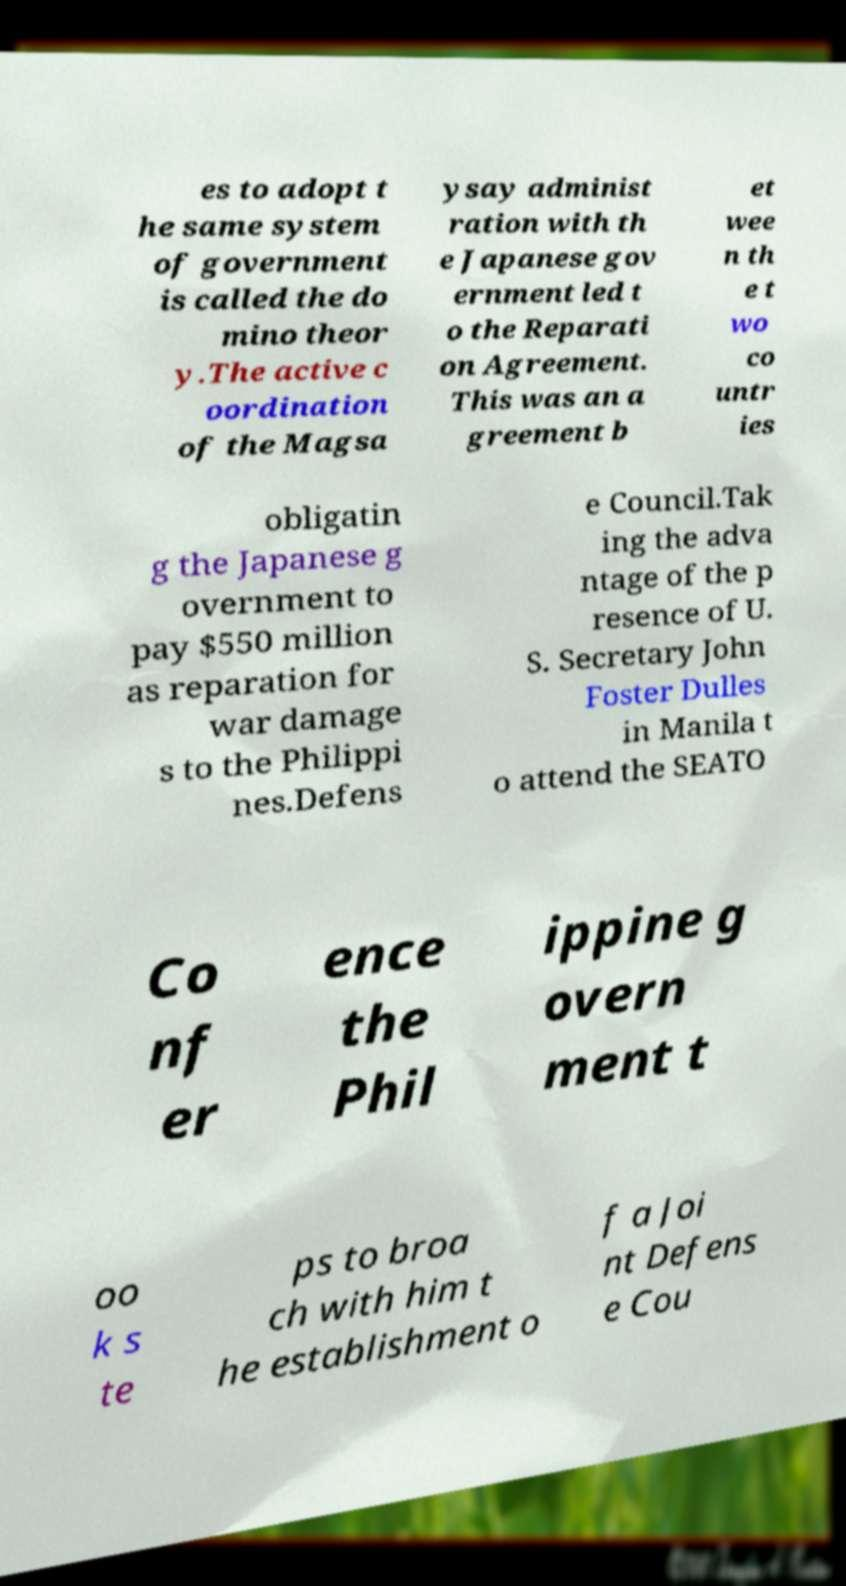For documentation purposes, I need the text within this image transcribed. Could you provide that? es to adopt t he same system of government is called the do mino theor y.The active c oordination of the Magsa ysay administ ration with th e Japanese gov ernment led t o the Reparati on Agreement. This was an a greement b et wee n th e t wo co untr ies obligatin g the Japanese g overnment to pay $550 million as reparation for war damage s to the Philippi nes.Defens e Council.Tak ing the adva ntage of the p resence of U. S. Secretary John Foster Dulles in Manila t o attend the SEATO Co nf er ence the Phil ippine g overn ment t oo k s te ps to broa ch with him t he establishment o f a Joi nt Defens e Cou 